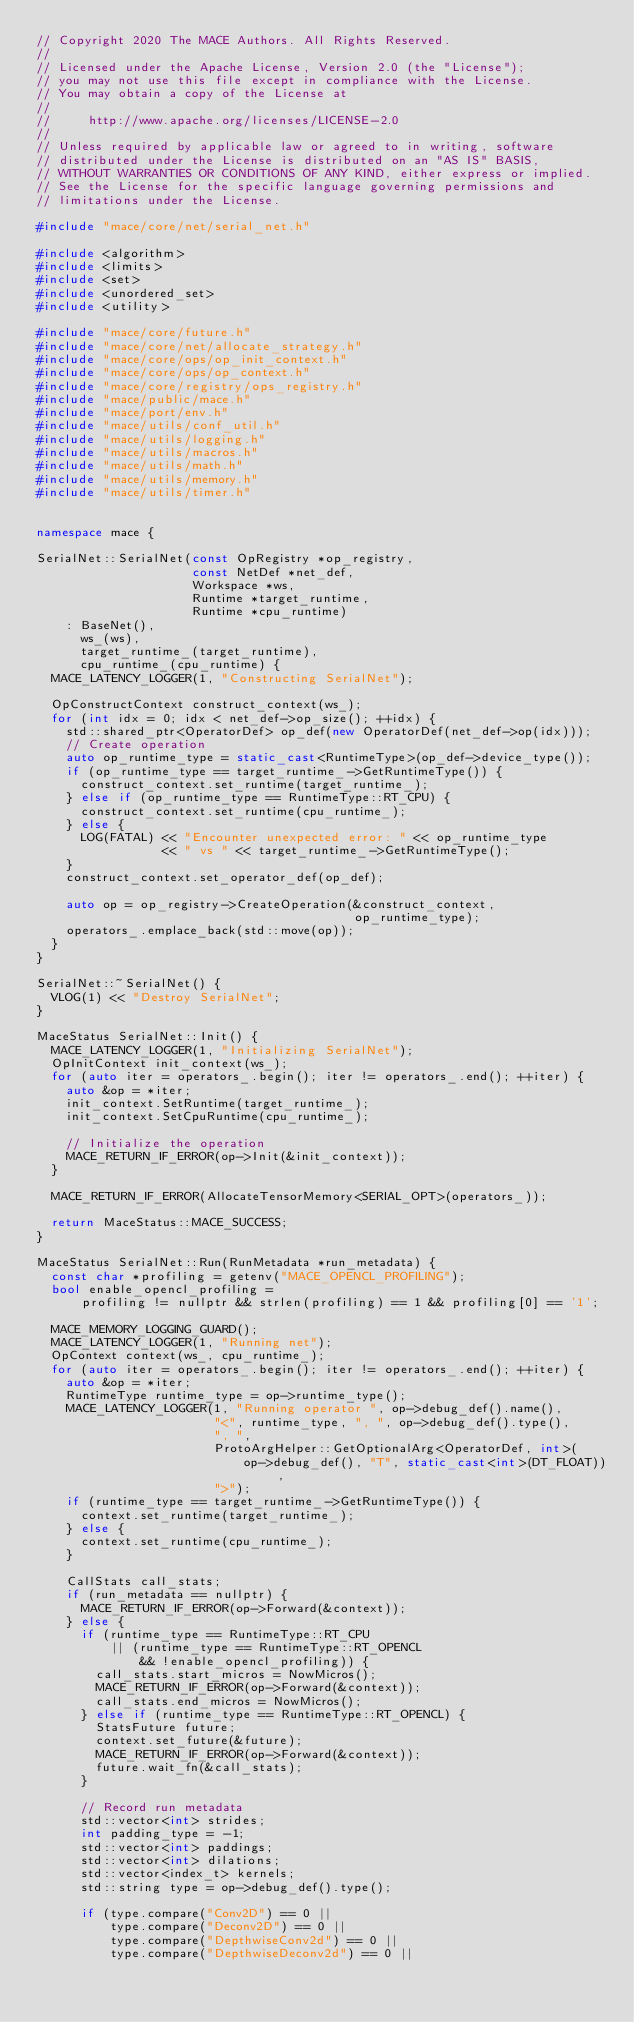Convert code to text. <code><loc_0><loc_0><loc_500><loc_500><_C++_>// Copyright 2020 The MACE Authors. All Rights Reserved.
//
// Licensed under the Apache License, Version 2.0 (the "License");
// you may not use this file except in compliance with the License.
// You may obtain a copy of the License at
//
//     http://www.apache.org/licenses/LICENSE-2.0
//
// Unless required by applicable law or agreed to in writing, software
// distributed under the License is distributed on an "AS IS" BASIS,
// WITHOUT WARRANTIES OR CONDITIONS OF ANY KIND, either express or implied.
// See the License for the specific language governing permissions and
// limitations under the License.

#include "mace/core/net/serial_net.h"

#include <algorithm>
#include <limits>
#include <set>
#include <unordered_set>
#include <utility>

#include "mace/core/future.h"
#include "mace/core/net/allocate_strategy.h"
#include "mace/core/ops/op_init_context.h"
#include "mace/core/ops/op_context.h"
#include "mace/core/registry/ops_registry.h"
#include "mace/public/mace.h"
#include "mace/port/env.h"
#include "mace/utils/conf_util.h"
#include "mace/utils/logging.h"
#include "mace/utils/macros.h"
#include "mace/utils/math.h"
#include "mace/utils/memory.h"
#include "mace/utils/timer.h"


namespace mace {

SerialNet::SerialNet(const OpRegistry *op_registry,
                     const NetDef *net_def,
                     Workspace *ws,
                     Runtime *target_runtime,
                     Runtime *cpu_runtime)
    : BaseNet(),
      ws_(ws),
      target_runtime_(target_runtime),
      cpu_runtime_(cpu_runtime) {
  MACE_LATENCY_LOGGER(1, "Constructing SerialNet");

  OpConstructContext construct_context(ws_);
  for (int idx = 0; idx < net_def->op_size(); ++idx) {
    std::shared_ptr<OperatorDef> op_def(new OperatorDef(net_def->op(idx)));
    // Create operation
    auto op_runtime_type = static_cast<RuntimeType>(op_def->device_type());
    if (op_runtime_type == target_runtime_->GetRuntimeType()) {
      construct_context.set_runtime(target_runtime_);
    } else if (op_runtime_type == RuntimeType::RT_CPU) {
      construct_context.set_runtime(cpu_runtime_);
    } else {
      LOG(FATAL) << "Encounter unexpected error: " << op_runtime_type
                 << " vs " << target_runtime_->GetRuntimeType();
    }
    construct_context.set_operator_def(op_def);

    auto op = op_registry->CreateOperation(&construct_context,
                                           op_runtime_type);
    operators_.emplace_back(std::move(op));
  }
}

SerialNet::~SerialNet() {
  VLOG(1) << "Destroy SerialNet";
}

MaceStatus SerialNet::Init() {
  MACE_LATENCY_LOGGER(1, "Initializing SerialNet");
  OpInitContext init_context(ws_);
  for (auto iter = operators_.begin(); iter != operators_.end(); ++iter) {
    auto &op = *iter;
    init_context.SetRuntime(target_runtime_);
    init_context.SetCpuRuntime(cpu_runtime_);

    // Initialize the operation
    MACE_RETURN_IF_ERROR(op->Init(&init_context));
  }

  MACE_RETURN_IF_ERROR(AllocateTensorMemory<SERIAL_OPT>(operators_));

  return MaceStatus::MACE_SUCCESS;
}

MaceStatus SerialNet::Run(RunMetadata *run_metadata) {
  const char *profiling = getenv("MACE_OPENCL_PROFILING");
  bool enable_opencl_profiling =
      profiling != nullptr && strlen(profiling) == 1 && profiling[0] == '1';

  MACE_MEMORY_LOGGING_GUARD();
  MACE_LATENCY_LOGGER(1, "Running net");
  OpContext context(ws_, cpu_runtime_);
  for (auto iter = operators_.begin(); iter != operators_.end(); ++iter) {
    auto &op = *iter;
    RuntimeType runtime_type = op->runtime_type();
    MACE_LATENCY_LOGGER(1, "Running operator ", op->debug_def().name(),
                        "<", runtime_type, ", ", op->debug_def().type(),
                        ", ",
                        ProtoArgHelper::GetOptionalArg<OperatorDef, int>(
                            op->debug_def(), "T", static_cast<int>(DT_FLOAT)),
                        ">");
    if (runtime_type == target_runtime_->GetRuntimeType()) {
      context.set_runtime(target_runtime_);
    } else {
      context.set_runtime(cpu_runtime_);
    }

    CallStats call_stats;
    if (run_metadata == nullptr) {
      MACE_RETURN_IF_ERROR(op->Forward(&context));
    } else {
      if (runtime_type == RuntimeType::RT_CPU
          || (runtime_type == RuntimeType::RT_OPENCL
              && !enable_opencl_profiling)) {
        call_stats.start_micros = NowMicros();
        MACE_RETURN_IF_ERROR(op->Forward(&context));
        call_stats.end_micros = NowMicros();
      } else if (runtime_type == RuntimeType::RT_OPENCL) {
        StatsFuture future;
        context.set_future(&future);
        MACE_RETURN_IF_ERROR(op->Forward(&context));
        future.wait_fn(&call_stats);
      }

      // Record run metadata
      std::vector<int> strides;
      int padding_type = -1;
      std::vector<int> paddings;
      std::vector<int> dilations;
      std::vector<index_t> kernels;
      std::string type = op->debug_def().type();

      if (type.compare("Conv2D") == 0 ||
          type.compare("Deconv2D") == 0 ||
          type.compare("DepthwiseConv2d") == 0 ||
          type.compare("DepthwiseDeconv2d") == 0 ||</code> 